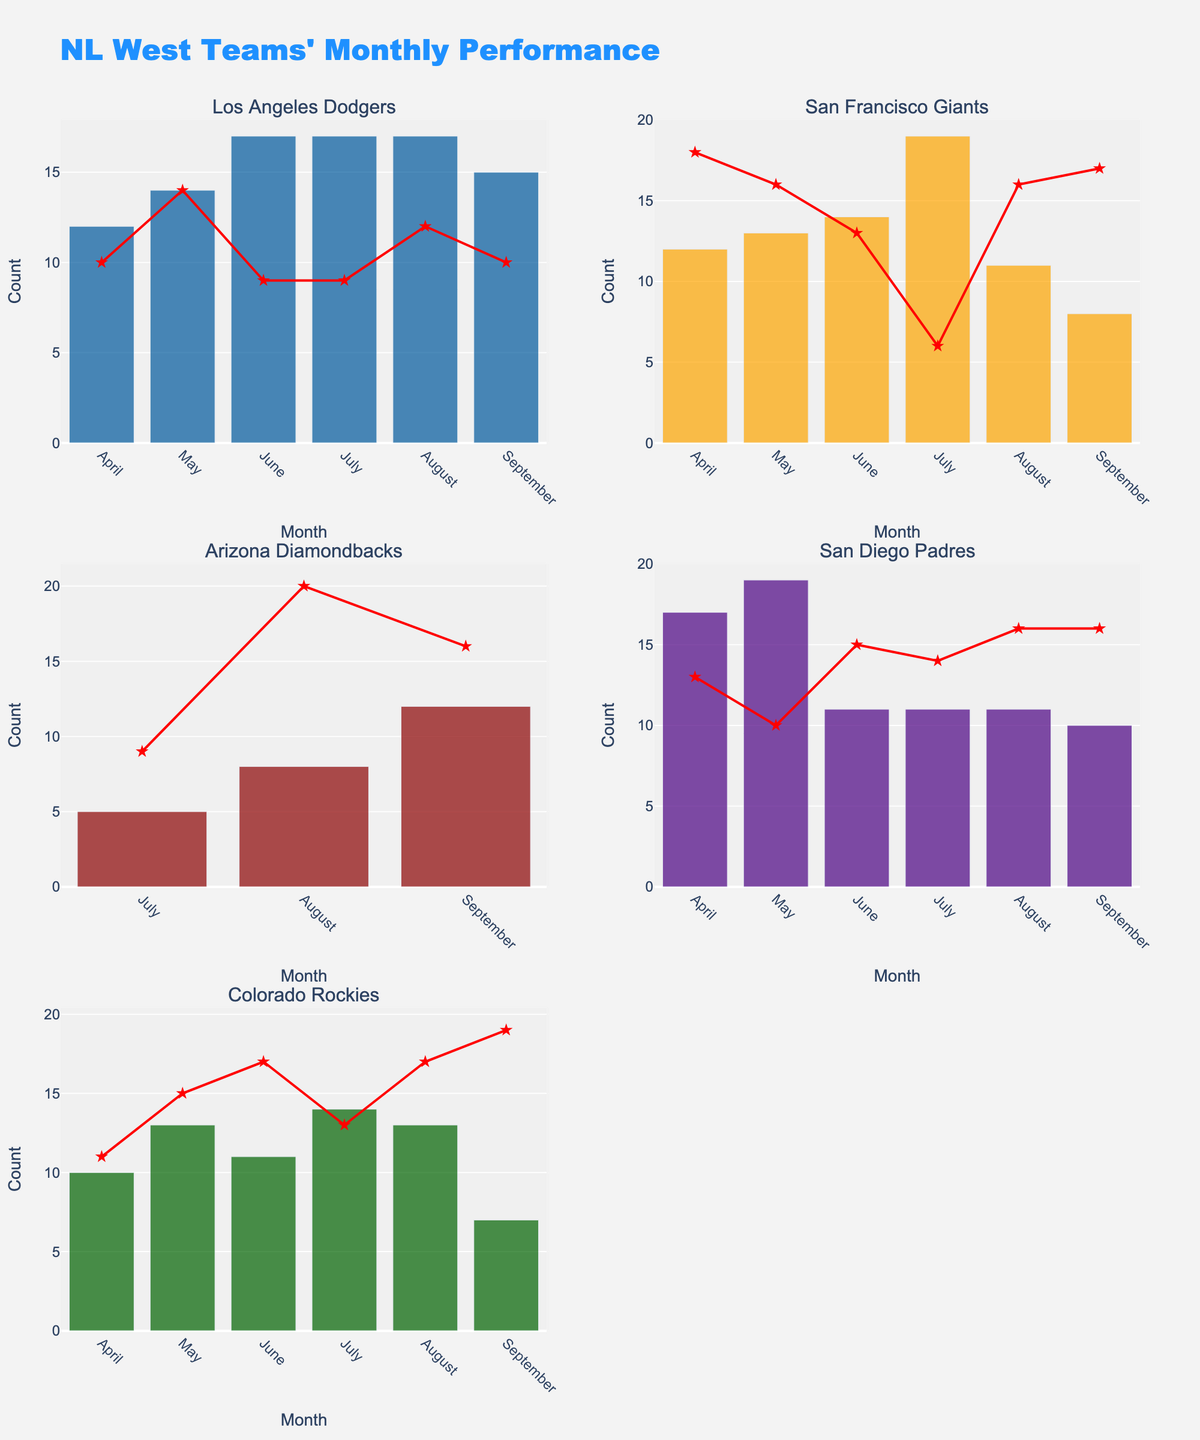What's the title of the figure? The title is often placed at the top-center of the figure and is designed to describe the main topic it represents. Here, we look to the main heading of the figure.
Answer: Age Distribution of Patients Receiving Low-Cost Eye Surgeries What is the age group with the highest percentage of patients? Identify the bar with the longest length, which represents the highest percentage, and check the corresponding age group label.
Answer: 46-60 What percentage of patients are in the 31-45 age group? Look for the bar labeled 31-45 and read off the percentage value, either from the text on the bar or the length of the bar on the x-axis.
Answer: 25% How many age groups are represented in the data? Count the number of distinct bars (or categories) along the y-axis.
Answer: 6 What is the combined percentage of patients in the 0-15 and 76+ age groups? Add the percentage values for the 0-15 and 76+ age groups: 8% + 5%.
Answer: 13% Which age group has the lowest percentage of patients? Identify the bar with the shortest length, which represents the smallest percentage, and check the corresponding age group label.
Answer: 76+ How much greater is the percentage of patients in the 16-30 age group compared to the 61-75 age group? Subtract the percentage value of the 61-75 age group from that of the 16-30 age group: 12% - 15%.
Answer: -3% Which age groups have a percentage of patients that is less than or equal to 15%? Identify the bars whose length (percentage values) is 15% or less and note the corresponding age groups: 0-15, 61-75, and 76+.
Answer: 0-15, 61-75, 76+ What is the average percentage of patients across all age groups? Sum the percentages of all age groups and divide by the number of age groups. (8 + 12 + 25 + 35 + 15 + 5) / 6 = 100 / 6
Answer: 16.67% How does the percentage of patients in the 46-60 age group compare to the average percentage across all groups? Find the average percentage calculated previously (16.67%) and compare it to the percentage for the 46-60 age group (35%).
Answer: The 46-60 age group percentage (35%) is higher than the average (16.67%) 